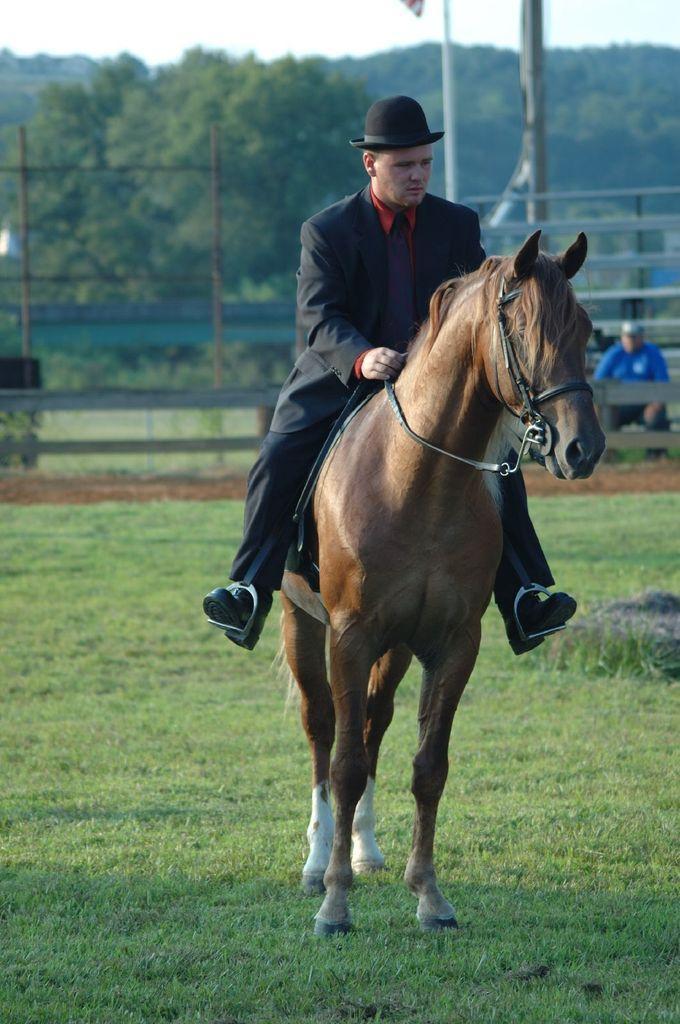Can you describe this image briefly? In the image we can see there is a man who is sitting on horse, the horse is on the ground the ground is covered with grass and the man is wearing formal suit and he is wearing a black hat. Behind there are lot of trees. 